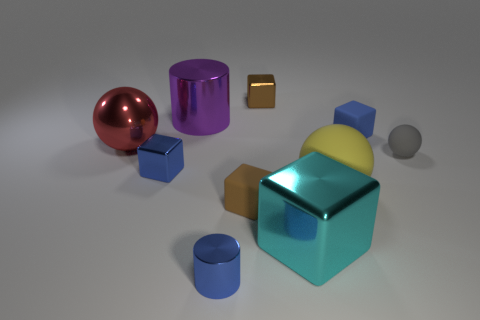Subtract all large shiny balls. How many balls are left? 2 Subtract 1 cubes. How many cubes are left? 4 Subtract all yellow spheres. How many spheres are left? 2 Subtract all purple cylinders. How many blue cubes are left? 2 Add 8 gray spheres. How many gray spheres exist? 9 Subtract 0 yellow blocks. How many objects are left? 10 Subtract all balls. How many objects are left? 7 Subtract all red balls. Subtract all gray cubes. How many balls are left? 2 Subtract all small cyan spheres. Subtract all cylinders. How many objects are left? 8 Add 1 blue metal objects. How many blue metal objects are left? 3 